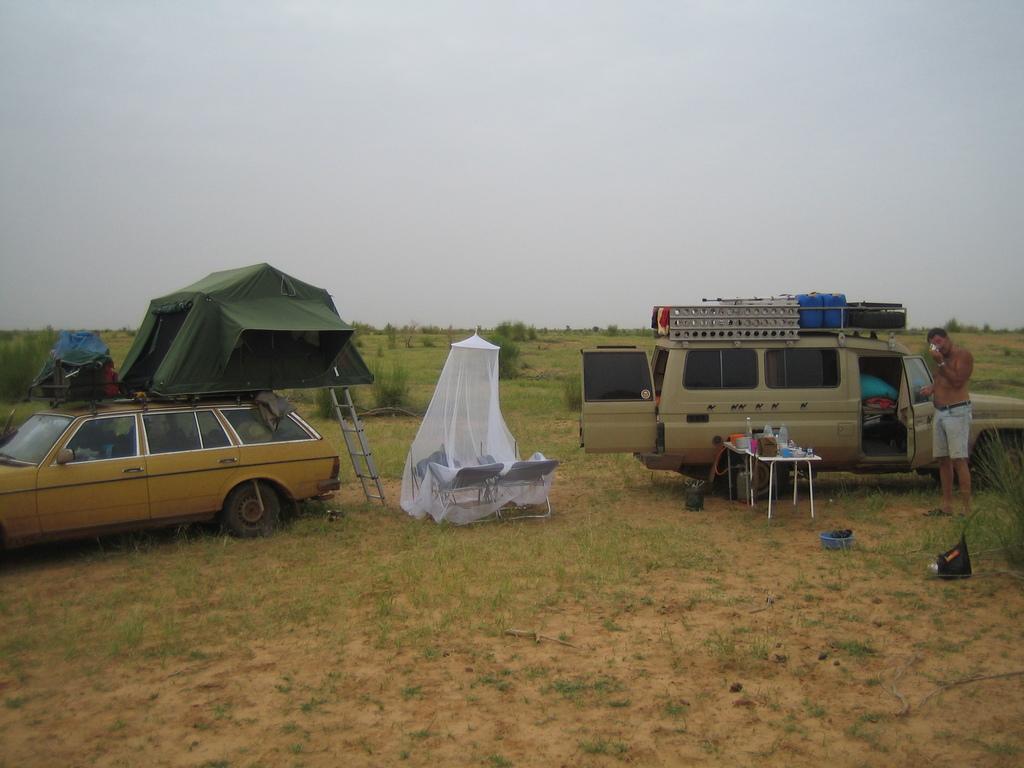Can you describe this image briefly? In the center of the picture there are cars, rent, umbrella, chairs, tables, people and various objects. In the foreground there is soil and grass. In the background there are trees and grass. At the top is is sky. 